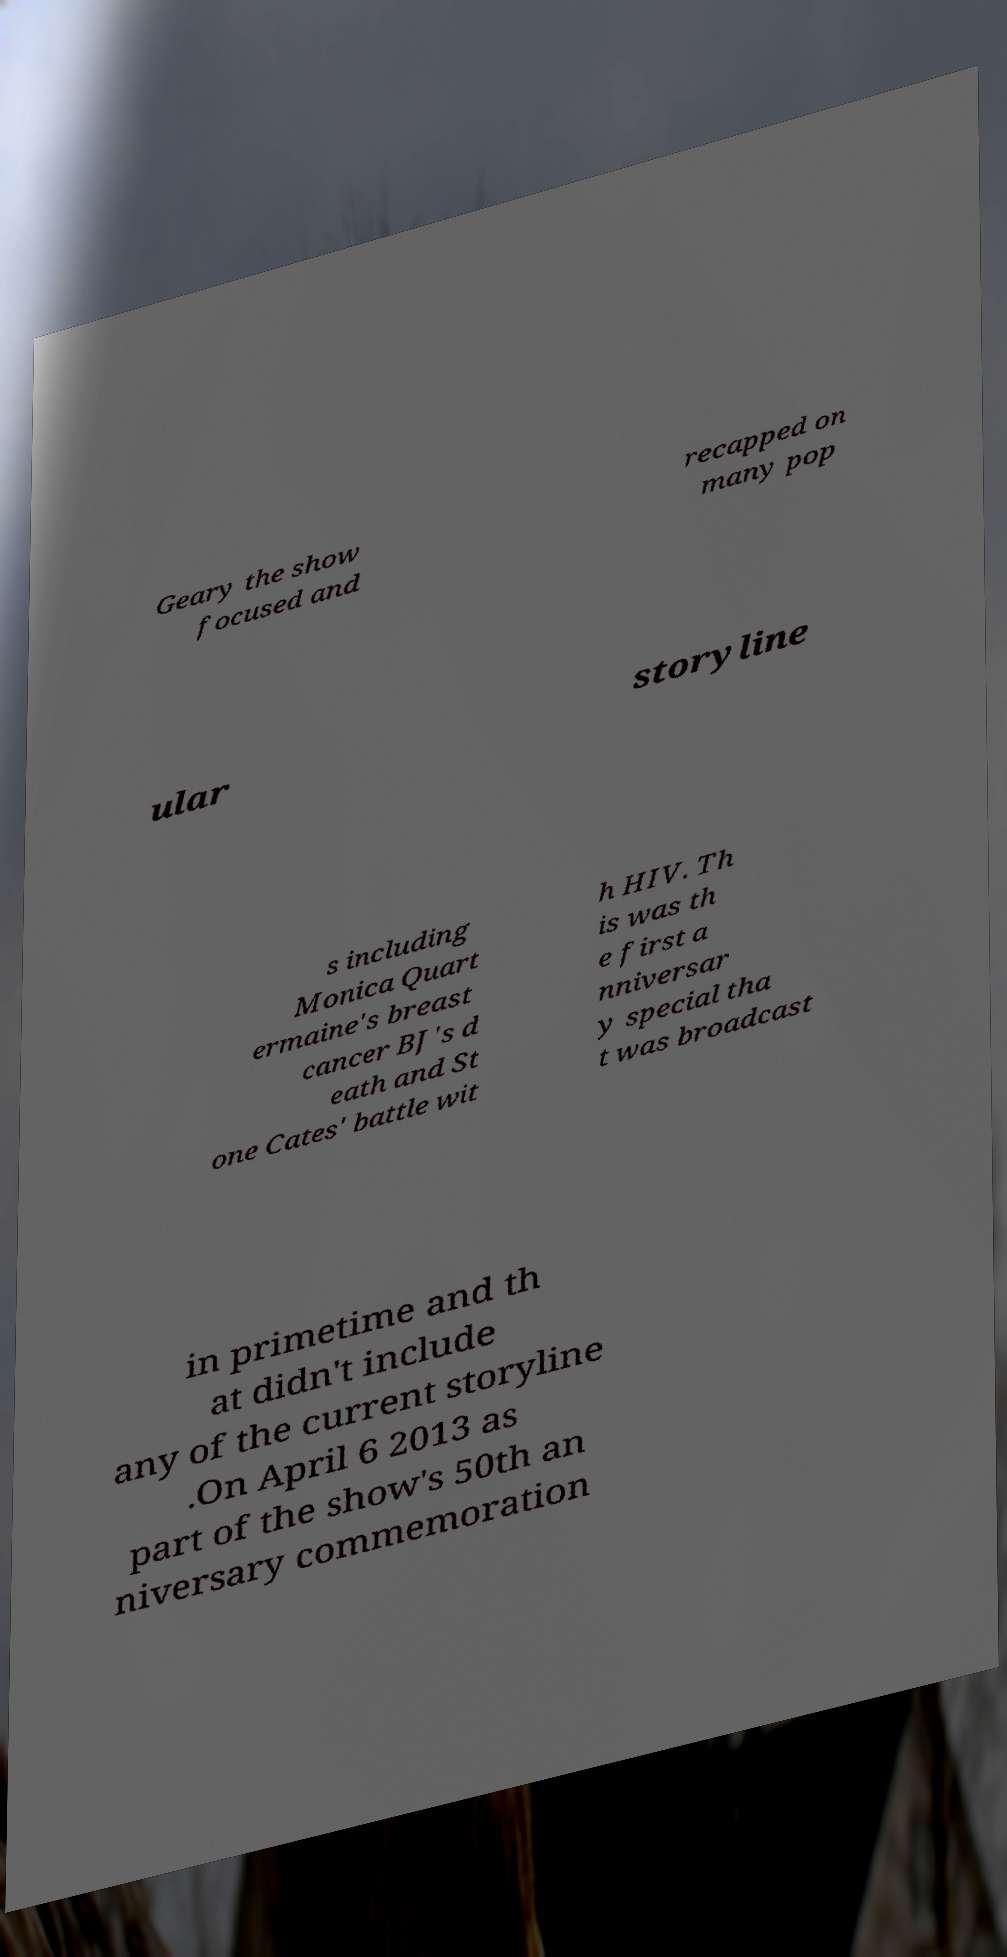Can you accurately transcribe the text from the provided image for me? Geary the show focused and recapped on many pop ular storyline s including Monica Quart ermaine's breast cancer BJ's d eath and St one Cates' battle wit h HIV. Th is was th e first a nniversar y special tha t was broadcast in primetime and th at didn't include any of the current storyline .On April 6 2013 as part of the show's 50th an niversary commemoration 